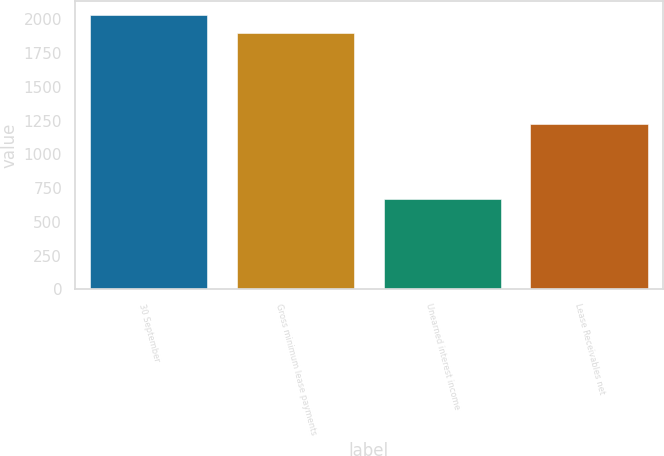Convert chart to OTSL. <chart><loc_0><loc_0><loc_500><loc_500><bar_chart><fcel>30 September<fcel>Gross minimum lease payments<fcel>Unearned interest income<fcel>Lease Receivables net<nl><fcel>2031.51<fcel>1897<fcel>671.9<fcel>1225.1<nl></chart> 